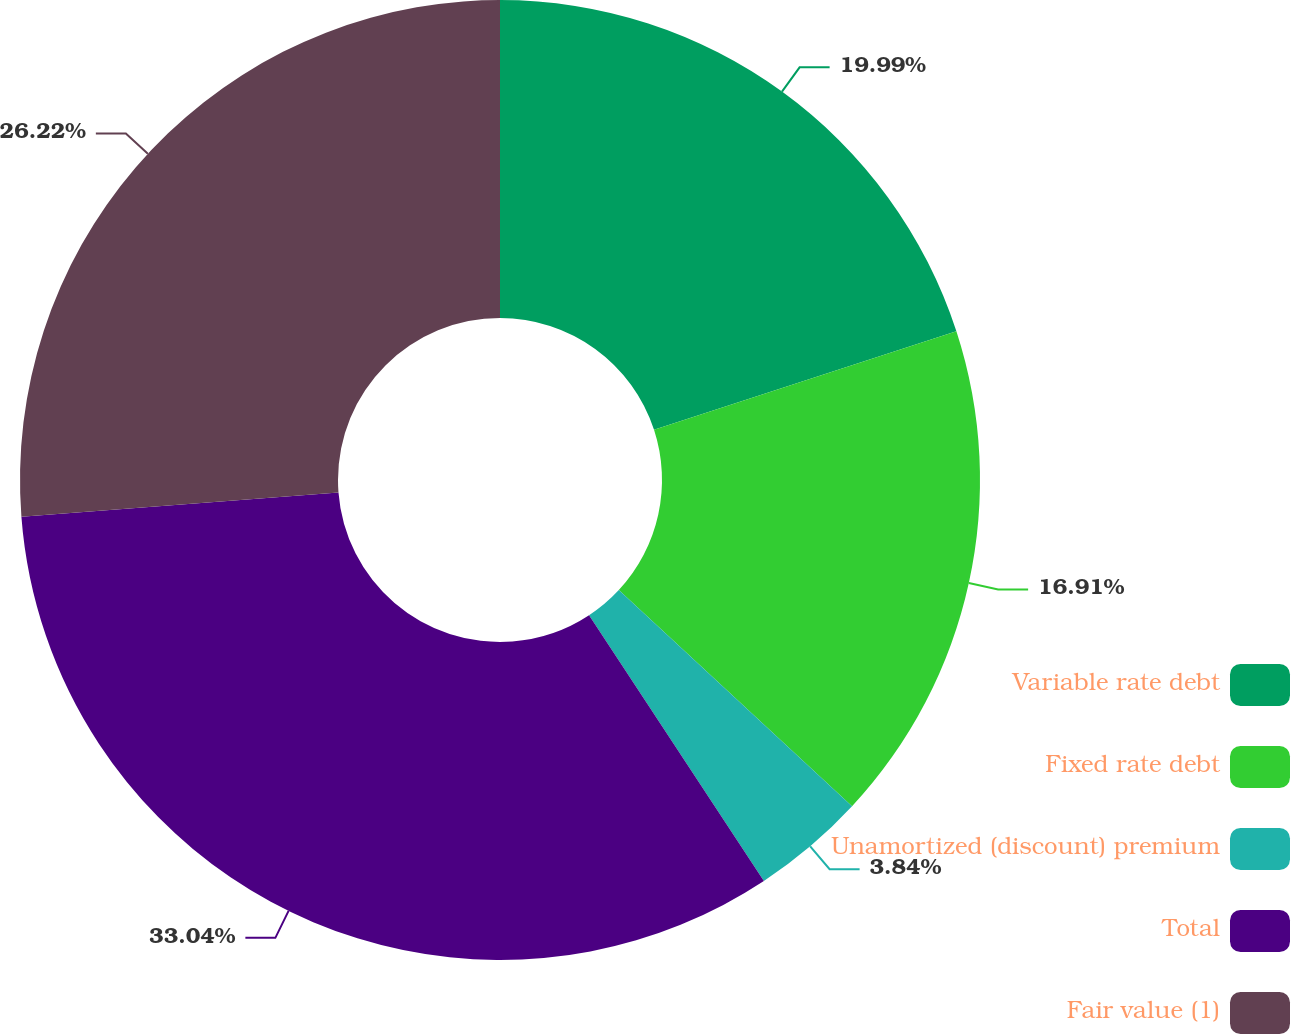<chart> <loc_0><loc_0><loc_500><loc_500><pie_chart><fcel>Variable rate debt<fcel>Fixed rate debt<fcel>Unamortized (discount) premium<fcel>Total<fcel>Fair value (1)<nl><fcel>19.99%<fcel>16.91%<fcel>3.84%<fcel>33.05%<fcel>26.22%<nl></chart> 